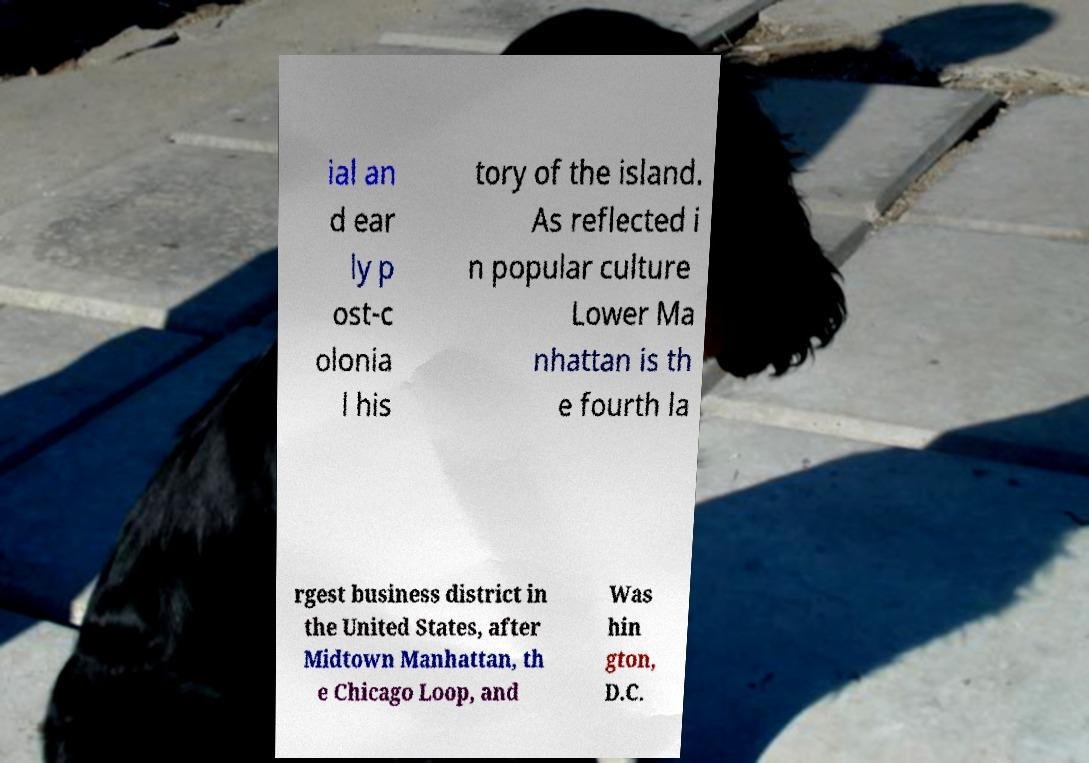There's text embedded in this image that I need extracted. Can you transcribe it verbatim? ial an d ear ly p ost-c olonia l his tory of the island. As reflected i n popular culture Lower Ma nhattan is th e fourth la rgest business district in the United States, after Midtown Manhattan, th e Chicago Loop, and Was hin gton, D.C. 